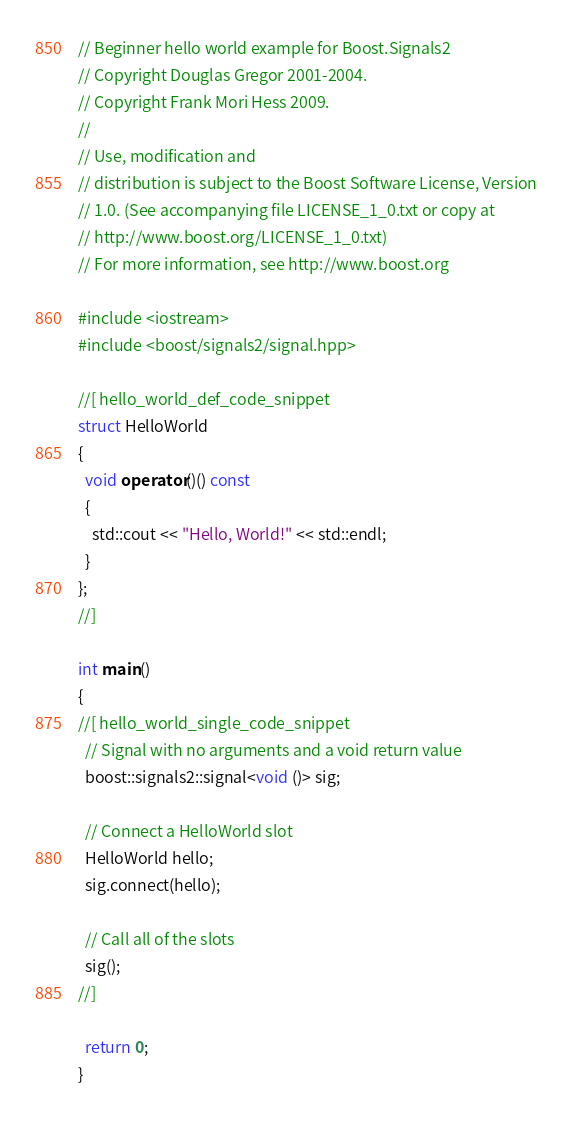Convert code to text. <code><loc_0><loc_0><loc_500><loc_500><_C++_>// Beginner hello world example for Boost.Signals2
// Copyright Douglas Gregor 2001-2004.
// Copyright Frank Mori Hess 2009.
//
// Use, modification and
// distribution is subject to the Boost Software License, Version
// 1.0. (See accompanying file LICENSE_1_0.txt or copy at
// http://www.boost.org/LICENSE_1_0.txt)
// For more information, see http://www.boost.org

#include <iostream>
#include <boost/signals2/signal.hpp>

//[ hello_world_def_code_snippet
struct HelloWorld
{
  void operator()() const
  {
    std::cout << "Hello, World!" << std::endl;
  }
};
//]

int main()
{
//[ hello_world_single_code_snippet
  // Signal with no arguments and a void return value
  boost::signals2::signal<void ()> sig;

  // Connect a HelloWorld slot
  HelloWorld hello;
  sig.connect(hello);

  // Call all of the slots
  sig();
//]

  return 0;
}
</code> 